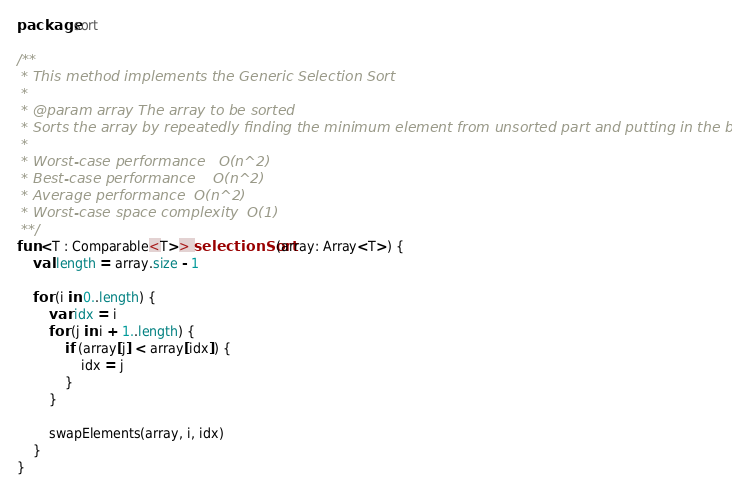<code> <loc_0><loc_0><loc_500><loc_500><_Kotlin_>package sort

/**
 * This method implements the Generic Selection Sort
 *
 * @param array The array to be sorted
 * Sorts the array by repeatedly finding the minimum element from unsorted part and putting in the beginning
 *
 * Worst-case performance	O(n^2)
 * Best-case performance	O(n^2)
 * Average performance	O(n^2)
 * Worst-case space complexity	O(1)
 **/
fun <T : Comparable<T>> selectionSort(array: Array<T>) {
    val length = array.size - 1

    for (i in 0..length) {
        var idx = i
        for (j in i + 1..length) {
            if (array[j] < array[idx]) {
                idx = j
            }
        }

        swapElements(array, i, idx)
    }
}
</code> 